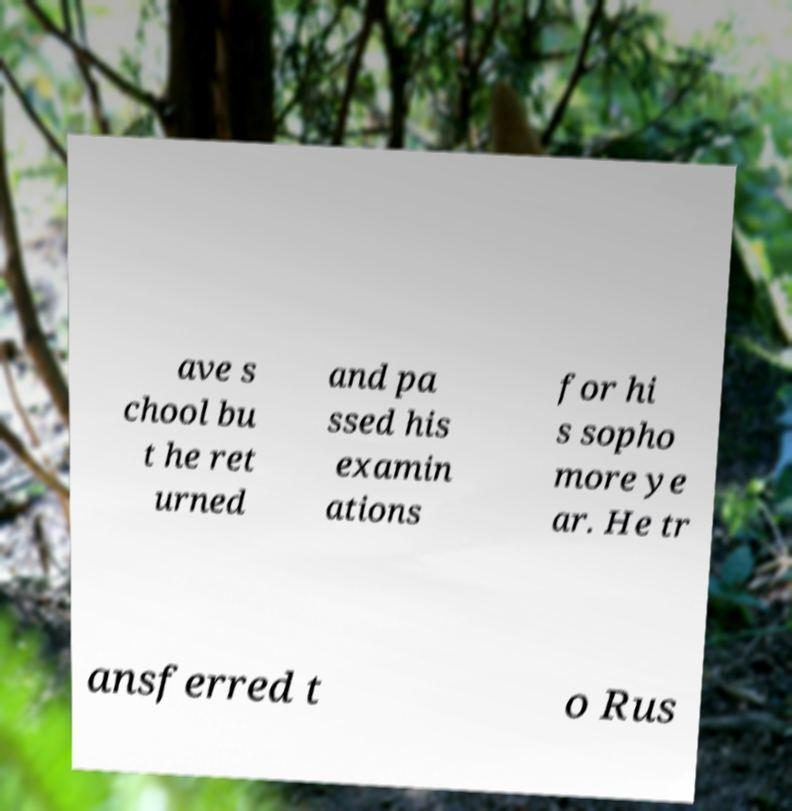For documentation purposes, I need the text within this image transcribed. Could you provide that? ave s chool bu t he ret urned and pa ssed his examin ations for hi s sopho more ye ar. He tr ansferred t o Rus 